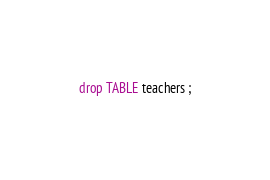Convert code to text. <code><loc_0><loc_0><loc_500><loc_500><_SQL_>drop TABLE teachers ;
</code> 